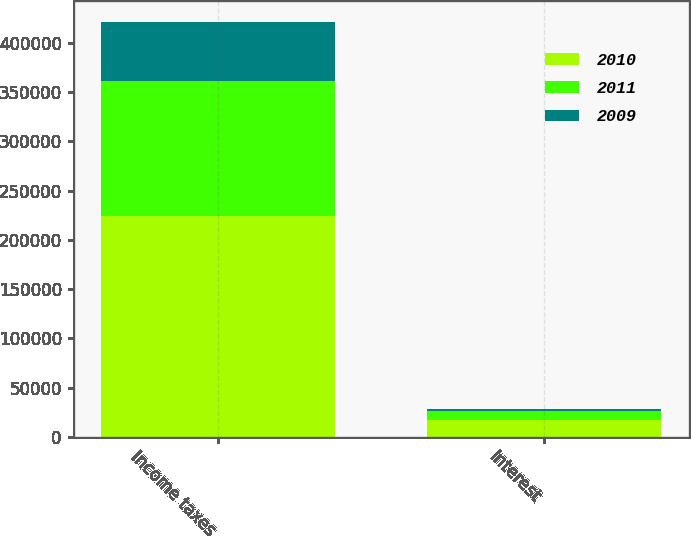Convert chart to OTSL. <chart><loc_0><loc_0><loc_500><loc_500><stacked_bar_chart><ecel><fcel>Income taxes<fcel>Interest<nl><fcel>2010<fcel>223716<fcel>16492<nl><fcel>2011<fcel>137149<fcel>9199<nl><fcel>2009<fcel>60609<fcel>2502<nl></chart> 